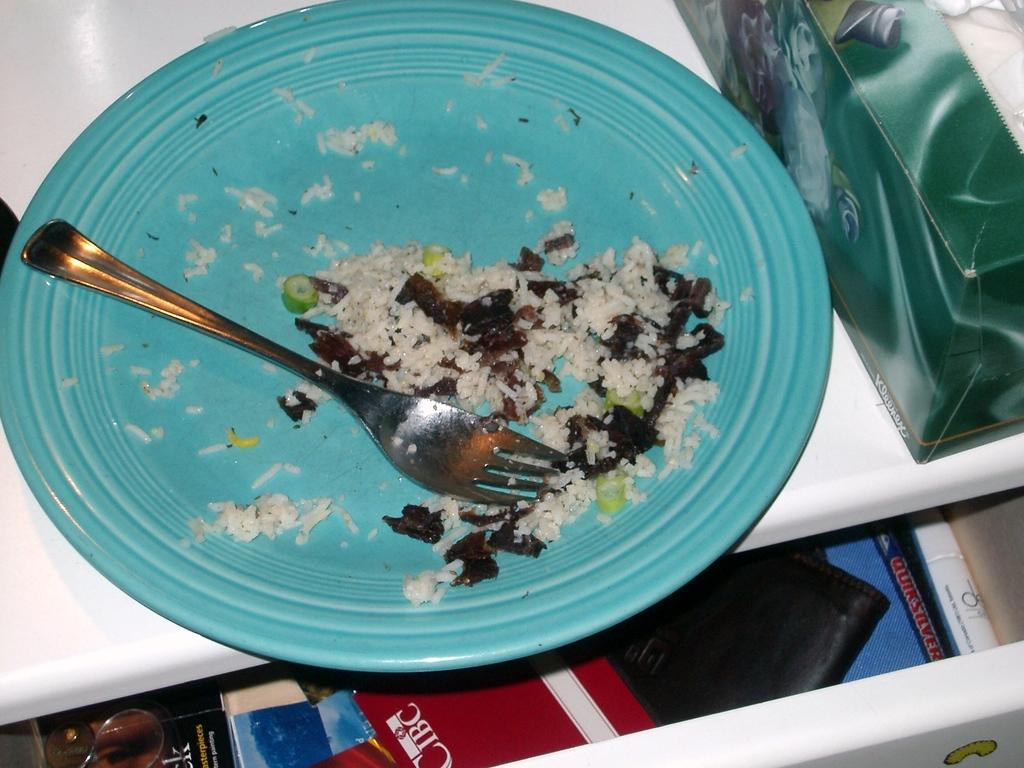What is the main object in the image? There is a box in the image. What else can be seen on the box? There is food on a plate in the image. What utensil is visible in the image? A fork is visible in the image. What is the surface that the box is placed on? There is a platform in the image. What other objects are present in the image? There are objects on a desk in the bottom portion of the image. How many people are jumping in the image? There are no people jumping in the image. What type of furniture is present in the image? There is no furniture present in the image. 